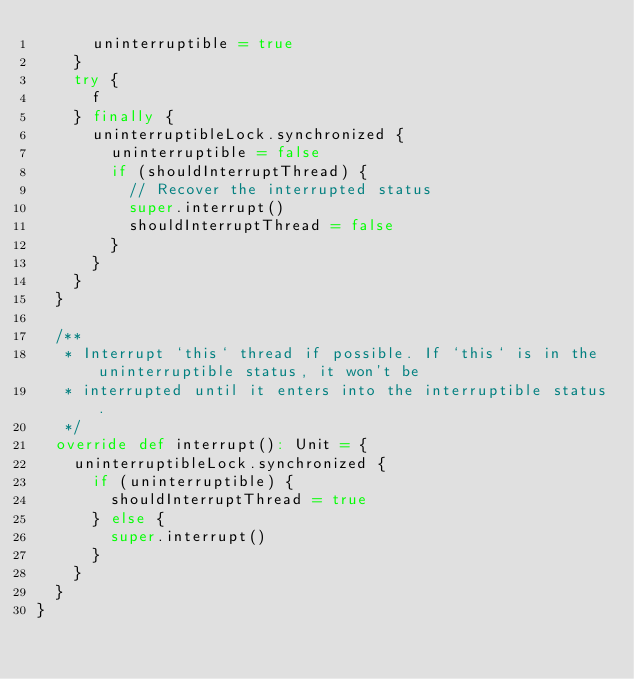<code> <loc_0><loc_0><loc_500><loc_500><_Scala_>      uninterruptible = true
    }
    try {
      f
    } finally {
      uninterruptibleLock.synchronized {
        uninterruptible = false
        if (shouldInterruptThread) {
          // Recover the interrupted status
          super.interrupt()
          shouldInterruptThread = false
        }
      }
    }
  }

  /**
   * Interrupt `this` thread if possible. If `this` is in the uninterruptible status, it won't be
   * interrupted until it enters into the interruptible status.
   */
  override def interrupt(): Unit = {
    uninterruptibleLock.synchronized {
      if (uninterruptible) {
        shouldInterruptThread = true
      } else {
        super.interrupt()
      }
    }
  }
}
</code> 